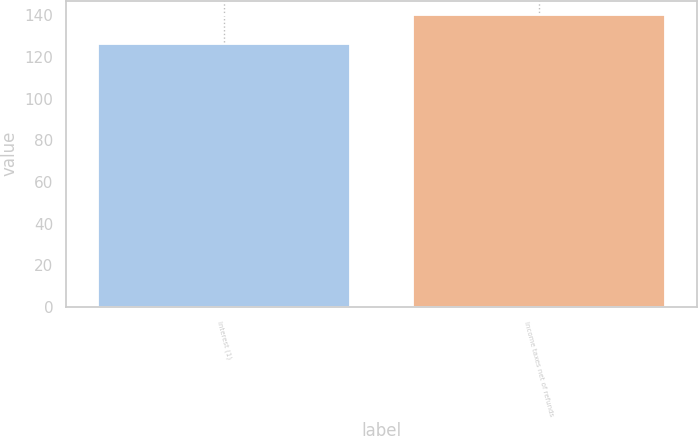Convert chart to OTSL. <chart><loc_0><loc_0><loc_500><loc_500><bar_chart><fcel>Interest (1)<fcel>Income taxes net of refunds<nl><fcel>126<fcel>140<nl></chart> 